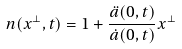<formula> <loc_0><loc_0><loc_500><loc_500>n ( x ^ { \perp } , t ) = 1 + \frac { \ddot { a } ( 0 , t ) } { \dot { a } ( 0 , t ) } x ^ { \perp }</formula> 